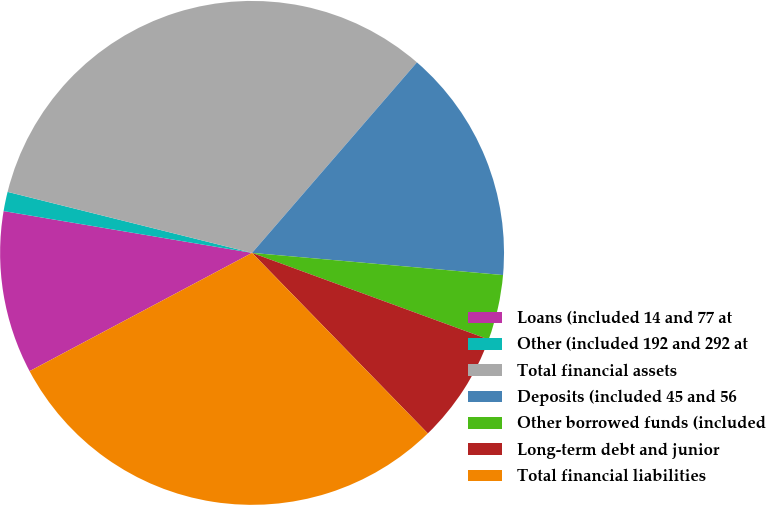<chart> <loc_0><loc_0><loc_500><loc_500><pie_chart><fcel>Loans (included 14 and 77 at<fcel>Other (included 192 and 292 at<fcel>Total financial assets<fcel>Deposits (included 45 and 56<fcel>Other borrowed funds (included<fcel>Long-term debt and junior<fcel>Total financial liabilities<nl><fcel>10.43%<fcel>1.24%<fcel>32.46%<fcel>15.05%<fcel>4.18%<fcel>7.13%<fcel>29.51%<nl></chart> 